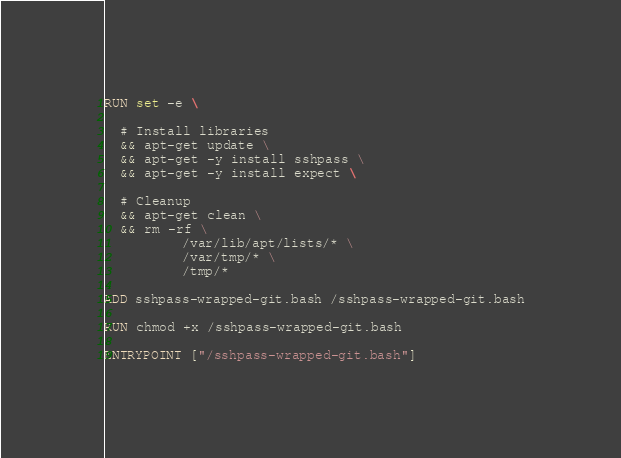Convert code to text. <code><loc_0><loc_0><loc_500><loc_500><_Dockerfile_>RUN set -e \

  # Install libraries
  && apt-get update \
  && apt-get -y install sshpass \
  && apt-get -y install expect \

  # Cleanup
  && apt-get clean \
  && rm -rf \
          /var/lib/apt/lists/* \
          /var/tmp/* \
          /tmp/*
          
ADD sshpass-wrapped-git.bash /sshpass-wrapped-git.bash

RUN chmod +x /sshpass-wrapped-git.bash

ENTRYPOINT ["/sshpass-wrapped-git.bash"]
</code> 